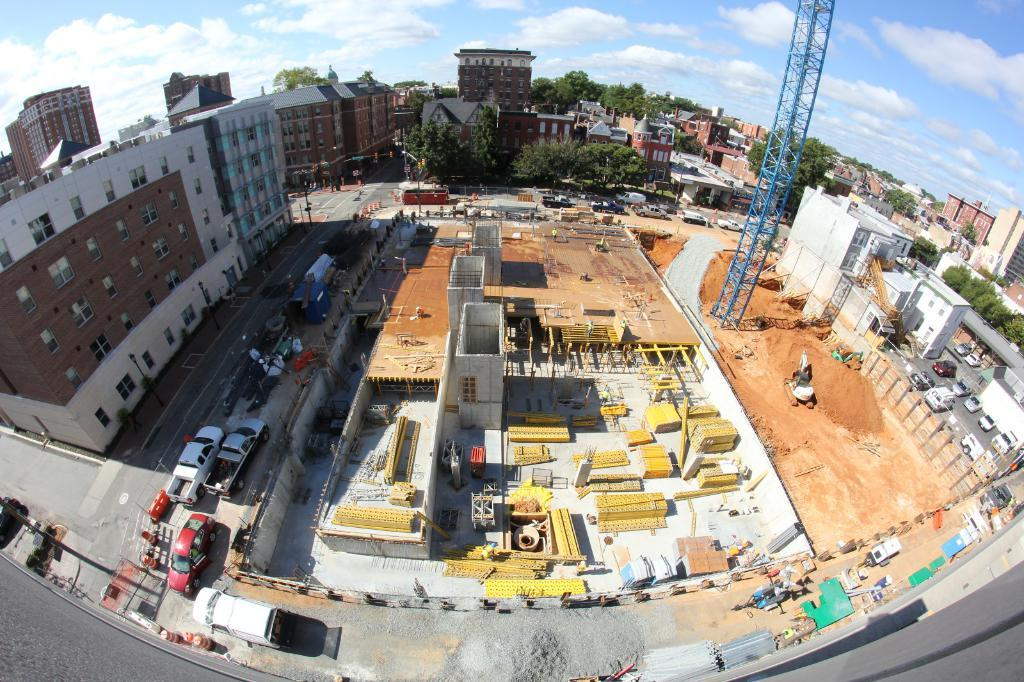What type of structures can be seen in the image? There are buildings in the image. What feature do the buildings have? The buildings have windows. What type of vegetation is present in the image? There are trees in the image. What are the poles used for in the image? The purpose of the poles is not specified, but they are likely used for support or signage. What is the ground condition in the image? There is mud visible in the image. What type of transportation is present in the image? There are vehicles on the road in the image. What activity is taking place in the image? There is a construction site in the image. What objects are present on the road in the image? There are objects on the road in the image, but their specific purpose is not mentioned. What type of beetle can be seen crawling on the construction site in the image? There is no beetle present in the image; it only features buildings, trees, poles, mud, vehicles, and a construction site. What is the temper of the workers at the construction site in the image? The image does not provide any information about the workers' temper or emotions. 